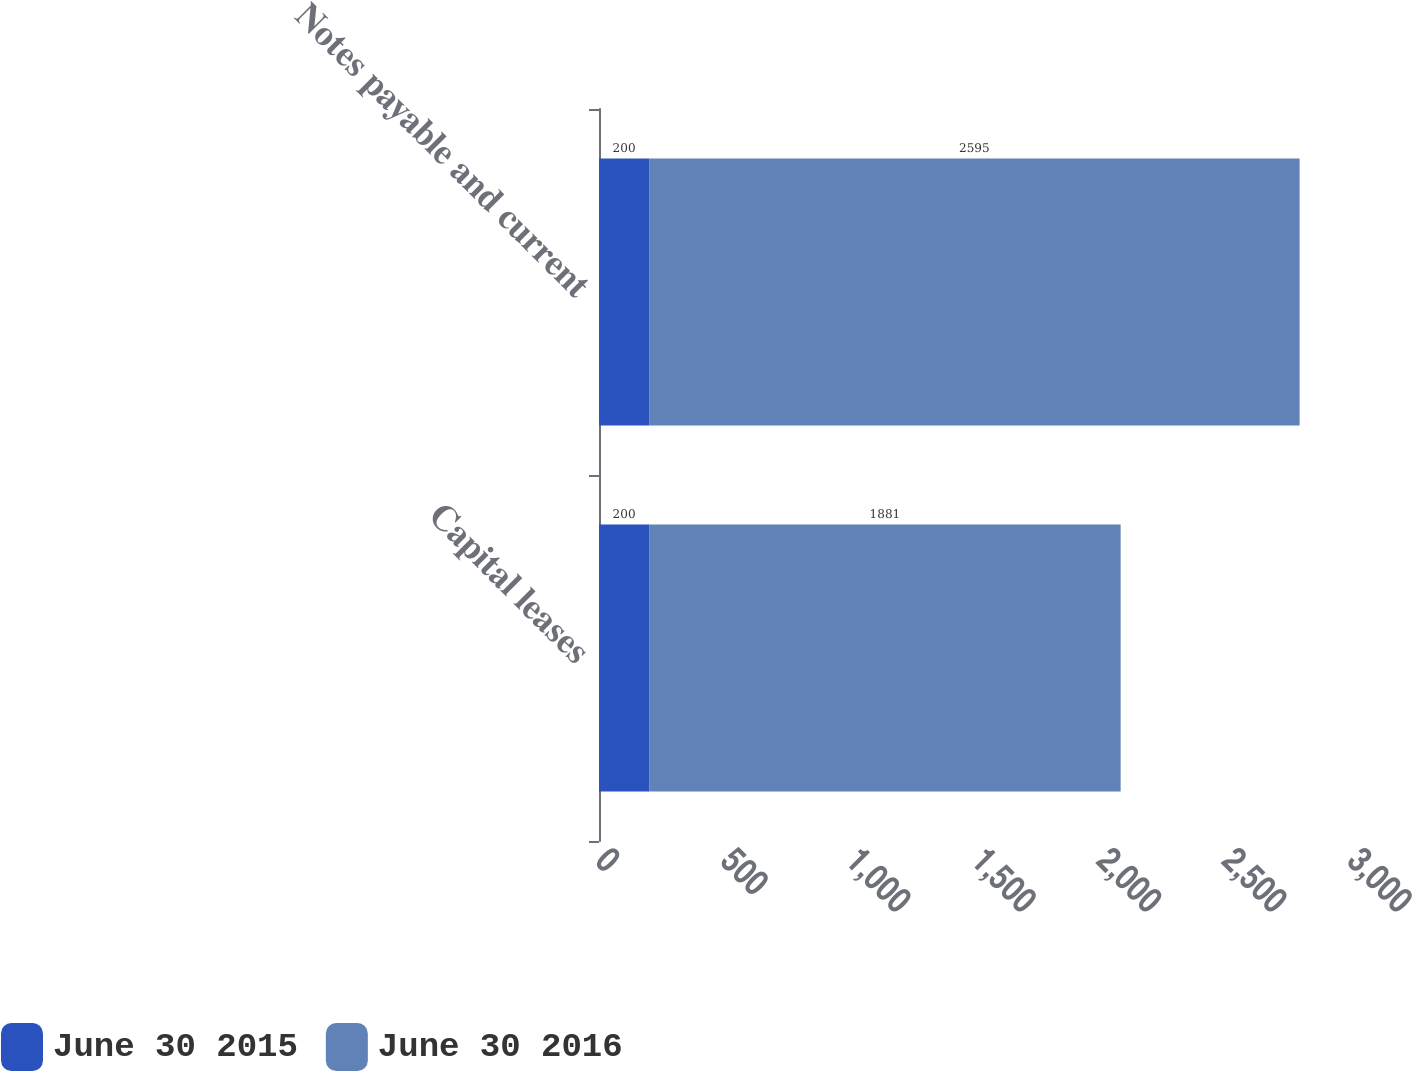Convert chart to OTSL. <chart><loc_0><loc_0><loc_500><loc_500><stacked_bar_chart><ecel><fcel>Capital leases<fcel>Notes payable and current<nl><fcel>June 30 2015<fcel>200<fcel>200<nl><fcel>June 30 2016<fcel>1881<fcel>2595<nl></chart> 